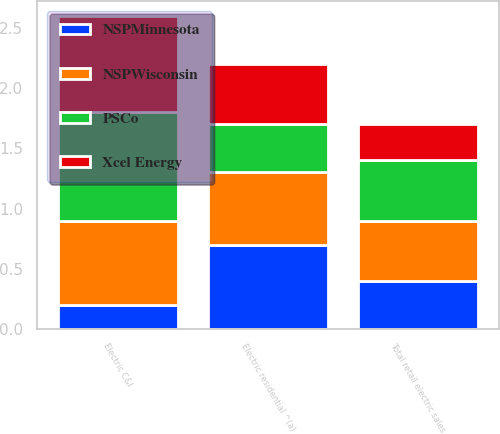<chart> <loc_0><loc_0><loc_500><loc_500><stacked_bar_chart><ecel><fcel>Electric residential ^(a)<fcel>Electric C&I<fcel>Total retail electric sales<nl><fcel>PSCo<fcel>0.4<fcel>0.9<fcel>0.5<nl><fcel>NSPMinnesota<fcel>0.7<fcel>0.2<fcel>0.4<nl><fcel>NSPWisconsin<fcel>0.6<fcel>0.7<fcel>0.5<nl><fcel>Xcel Energy<fcel>0.5<fcel>0.8<fcel>0.3<nl></chart> 